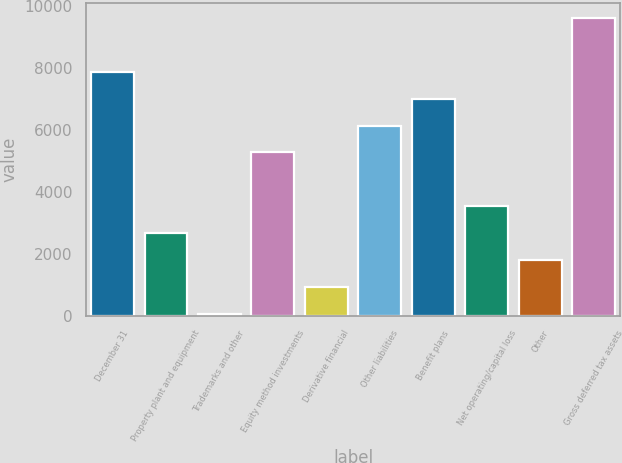Convert chart. <chart><loc_0><loc_0><loc_500><loc_500><bar_chart><fcel>December 31<fcel>Property plant and equipment<fcel>Trademarks and other<fcel>Equity method investments<fcel>Derivative financial<fcel>Other liabilities<fcel>Benefit plans<fcel>Net operating/capital loss<fcel>Other<fcel>Gross deferred tax assets<nl><fcel>7878.2<fcel>2671.4<fcel>68<fcel>5274.8<fcel>935.8<fcel>6142.6<fcel>7010.4<fcel>3539.2<fcel>1803.6<fcel>9613.8<nl></chart> 